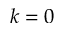<formula> <loc_0><loc_0><loc_500><loc_500>k = 0</formula> 